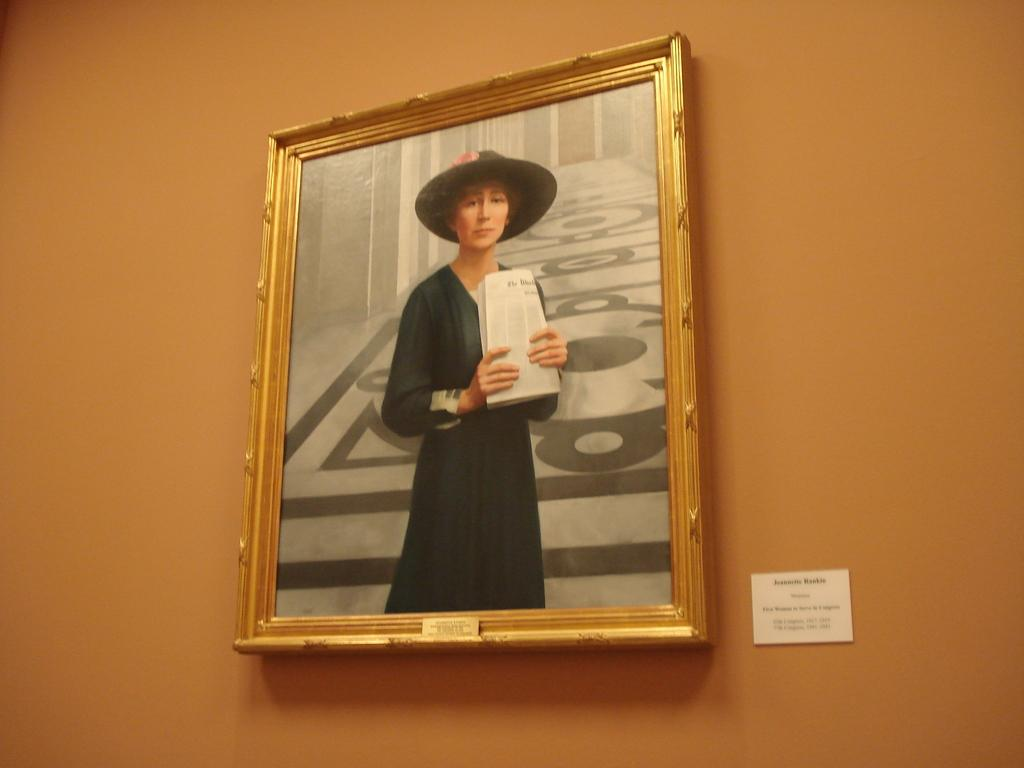What is hanging on the wall in the image? There is a frame and a board on the wall. What is inside the frame? The frame contains a person. What is the person wearing in the image? The person is wearing a hat. What is the person holding in the image? The person is holding papers. What type of memory is used in the frame to store the image of the person? The frame is not a digital device, so it does not use memory to store the image of the person. How is the person being transported in the image? The person is not being transported in the image; they are depicted in a static pose within the frame. 